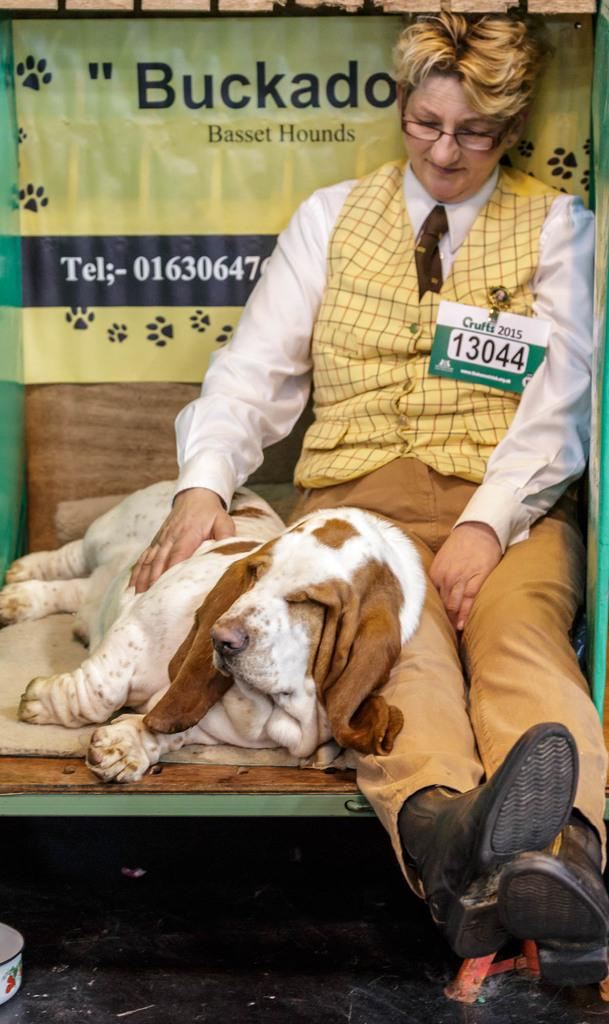What type of animal can be seen in the image? There is a dog in the image. How is the dog positioned in relation to the person? The dog is lying beside a person. What is the person doing in the image? The person is sitting. What can be seen in the background of the image? There is an advertisement in the background of the image. What type of form is the dog filling out in the image? There is no form present in the image, and the dog is not filling out any form. Can you see any turkeys in the image? There are no turkeys present in the image. 